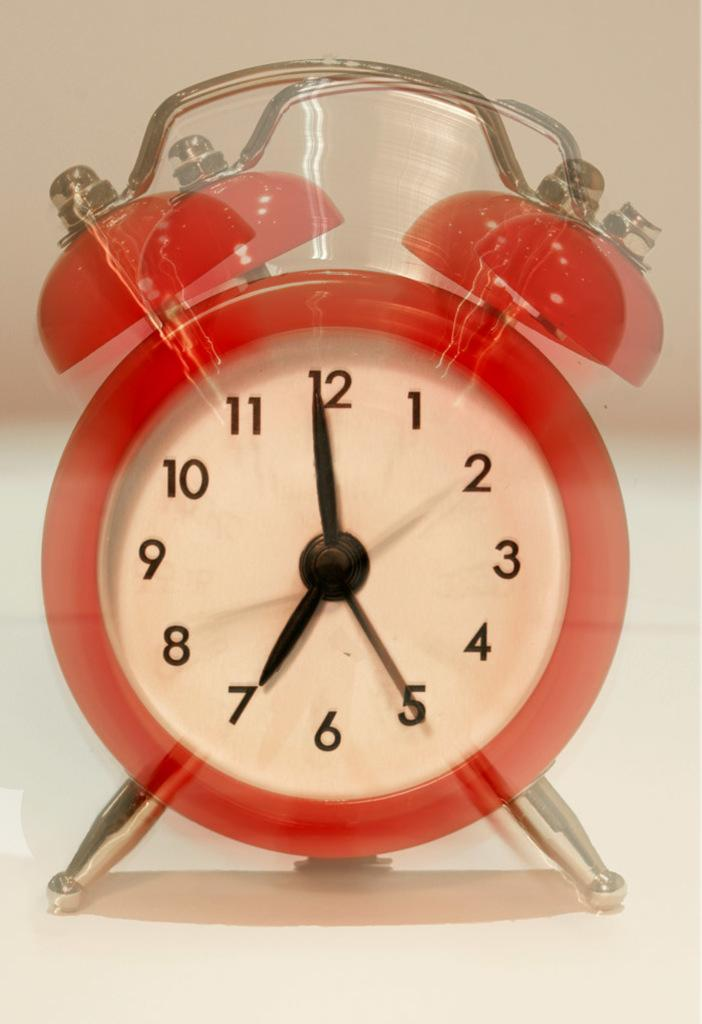<image>
Offer a succinct explanation of the picture presented. A red alarm clock shows the time 6:59. 